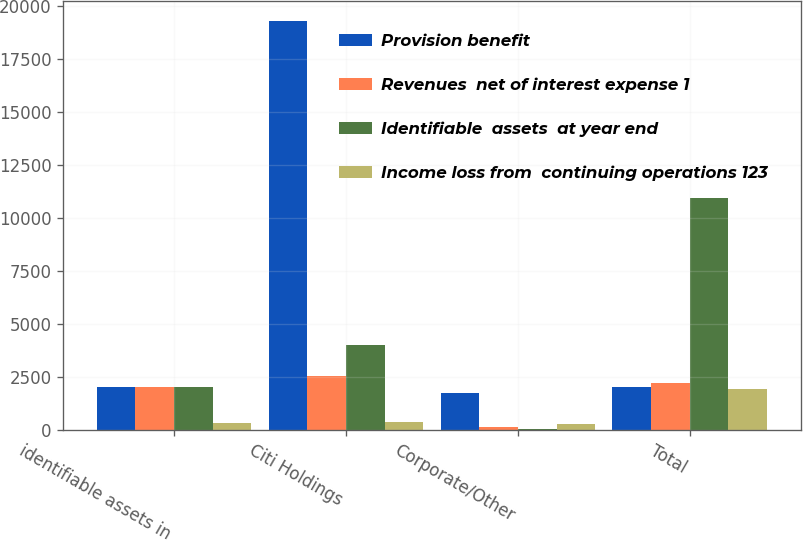Convert chart. <chart><loc_0><loc_0><loc_500><loc_500><stacked_bar_chart><ecel><fcel>identifiable assets in<fcel>Citi Holdings<fcel>Corporate/Other<fcel>Total<nl><fcel>Provision benefit<fcel>2010<fcel>19287<fcel>1754<fcel>2010<nl><fcel>Revenues  net of interest expense 1<fcel>2010<fcel>2554<fcel>153<fcel>2233<nl><fcel>Identifiable  assets  at year end<fcel>2010<fcel>4023<fcel>46<fcel>10951<nl><fcel>Income loss from  continuing operations 123<fcel>330<fcel>359<fcel>272<fcel>1914<nl></chart> 